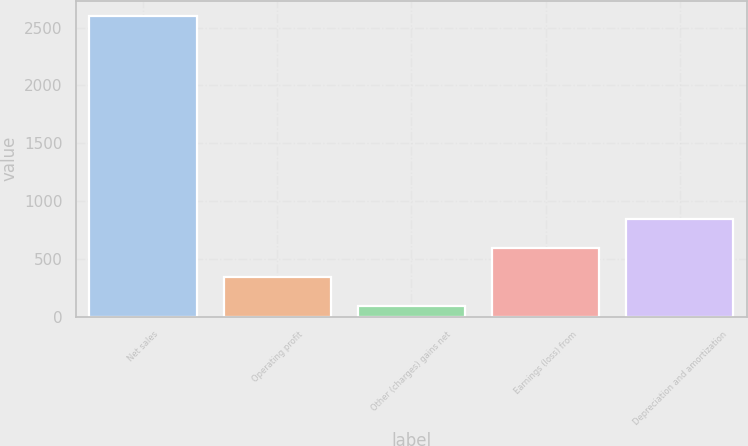Convert chart. <chart><loc_0><loc_0><loc_500><loc_500><bar_chart><fcel>Net sales<fcel>Operating profit<fcel>Other (charges) gains net<fcel>Earnings (loss) from<fcel>Depreciation and amortization<nl><fcel>2603<fcel>342.2<fcel>91<fcel>593.4<fcel>844.6<nl></chart> 